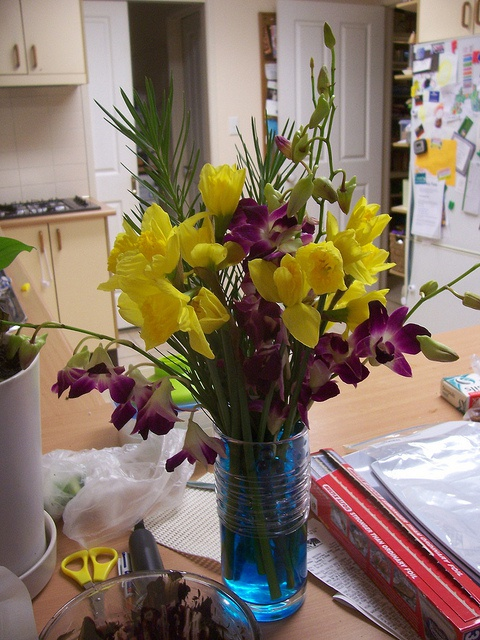Describe the objects in this image and their specific colors. I can see potted plant in gray, black, and olive tones, book in gray, lavender, maroon, brown, and black tones, refrigerator in gray, lightgray, and darkgray tones, vase in gray, black, navy, and blue tones, and potted plant in gray and black tones in this image. 